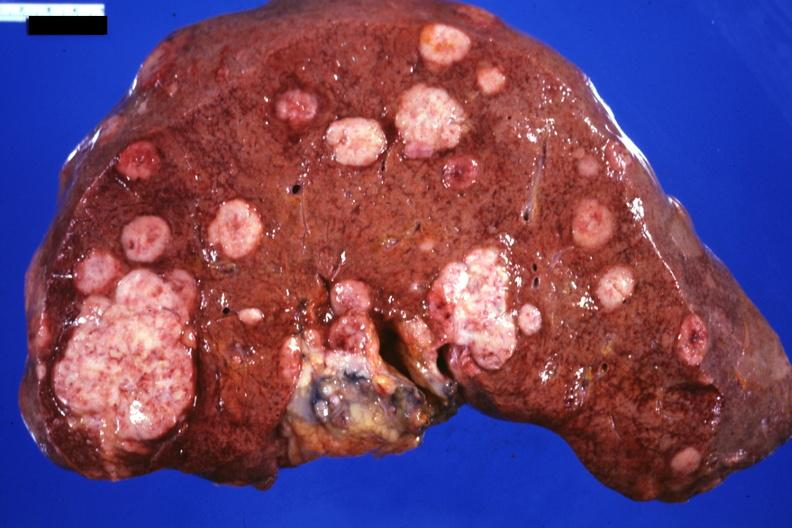what is present?
Answer the question using a single word or phrase. Liver 